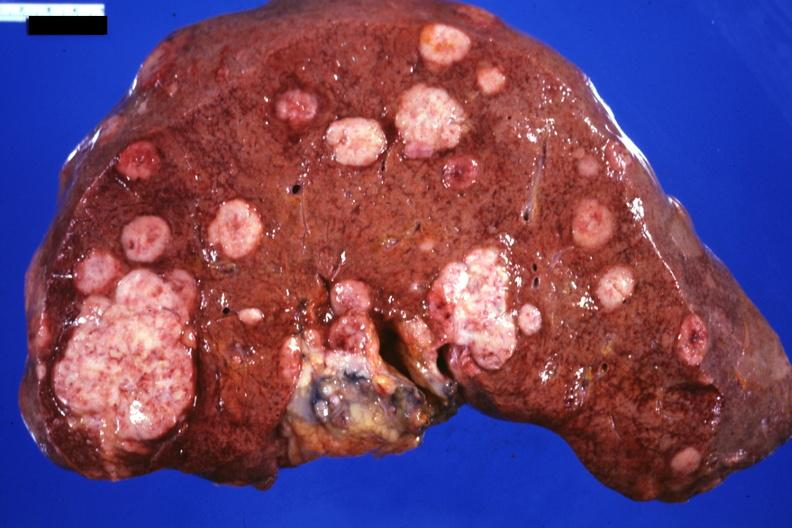what is present?
Answer the question using a single word or phrase. Liver 